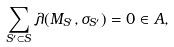Convert formula to latex. <formula><loc_0><loc_0><loc_500><loc_500>\sum _ { S ^ { \prime } \subset S } \lambda ( M _ { S ^ { \prime } } , \sigma _ { S ^ { \prime } } ) = 0 \in A ,</formula> 